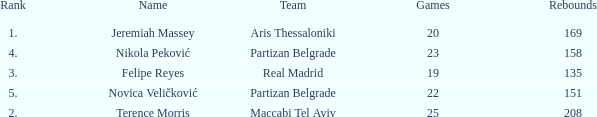How many Games for Terence Morris? 25.0. Could you parse the entire table? {'header': ['Rank', 'Name', 'Team', 'Games', 'Rebounds'], 'rows': [['1.', 'Jeremiah Massey', 'Aris Thessaloniki', '20', '169'], ['4.', 'Nikola Peković', 'Partizan Belgrade', '23', '158'], ['3.', 'Felipe Reyes', 'Real Madrid', '19', '135'], ['5.', 'Novica Veličković', 'Partizan Belgrade', '22', '151'], ['2.', 'Terence Morris', 'Maccabi Tel Aviv', '25', '208']]} 